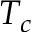Convert formula to latex. <formula><loc_0><loc_0><loc_500><loc_500>T _ { c }</formula> 